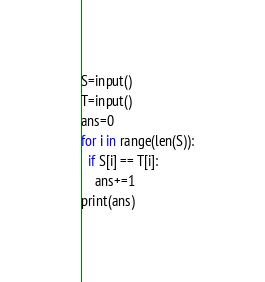Convert code to text. <code><loc_0><loc_0><loc_500><loc_500><_Python_>S=input()
T=input()
ans=0
for i in range(len(S)):
  if S[i] == T[i]:
    ans+=1
print(ans)</code> 